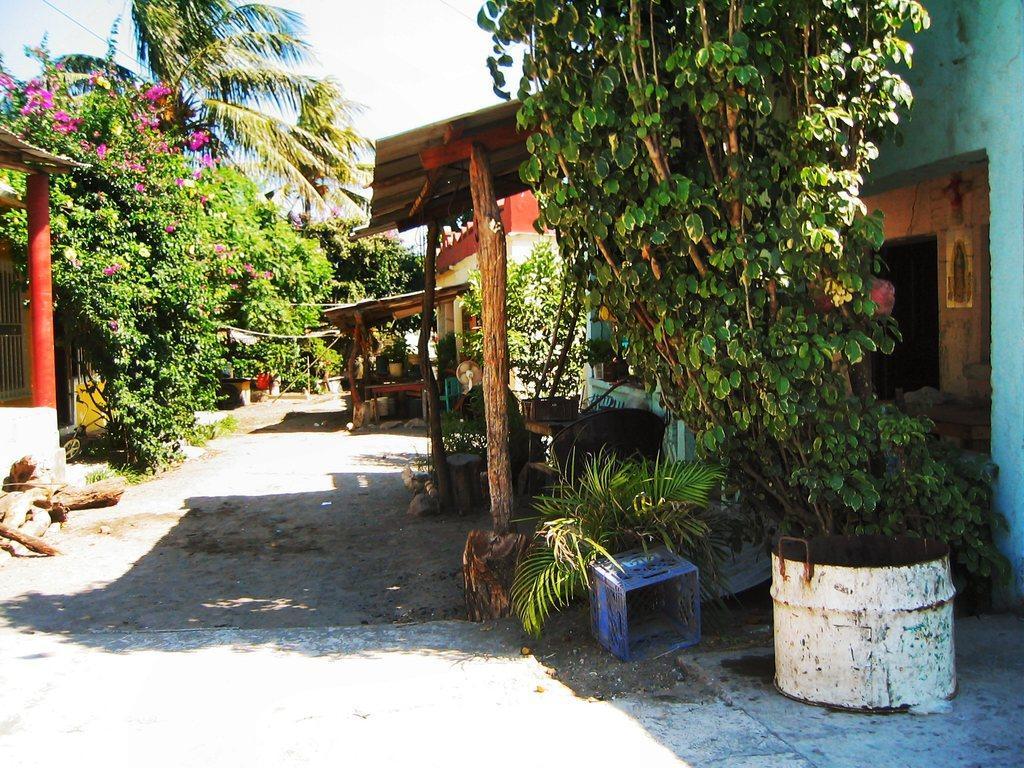Describe this image in one or two sentences. This picture shows houses and we see trees and a tree bark on the ground. We see plastic basket and a cloudy sky. 